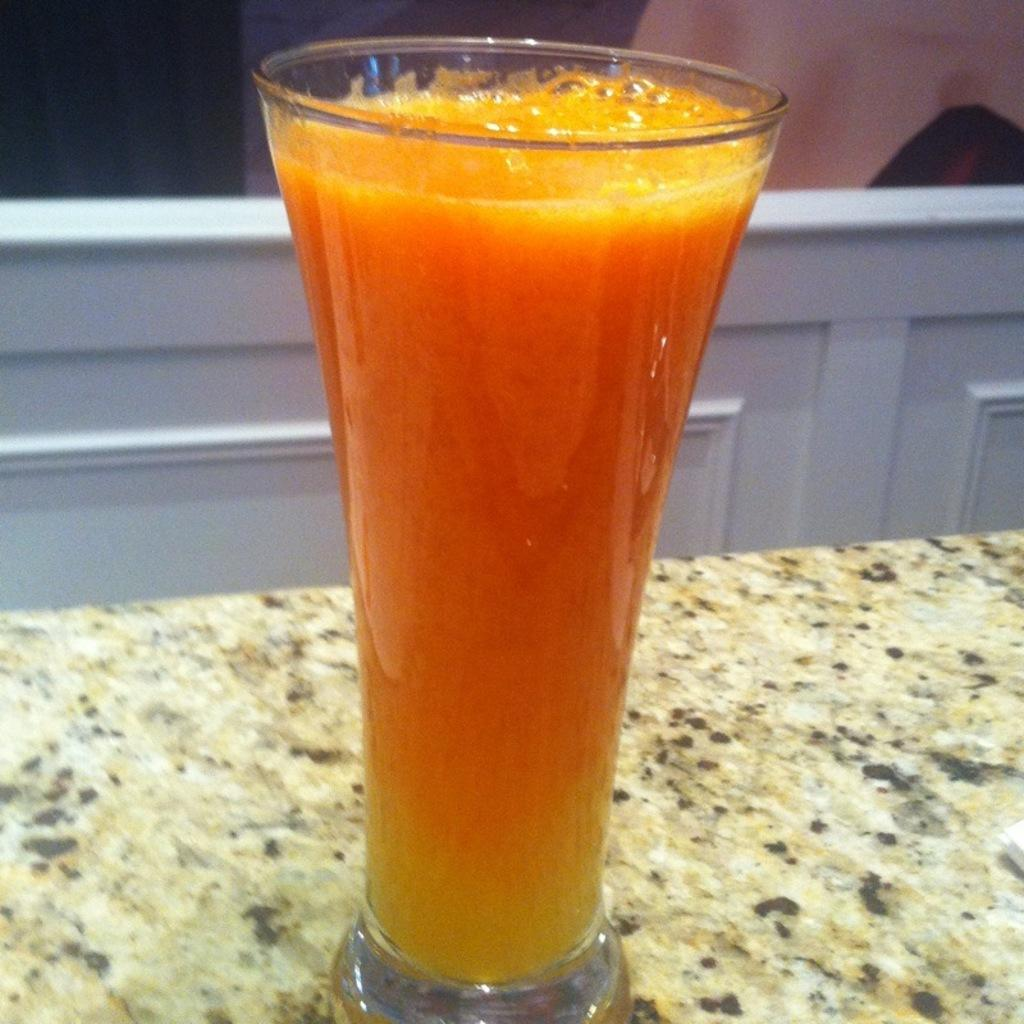What is in the glass that is visible in the image? There is a glass filled with juice in the image. Where is the glass located in the image? The glass is placed on a table. What type of zipper can be seen on the glass in the image? There is no zipper present on the glass in the image. What color is the zebra standing next to the table in the image? There is no zebra present in the image. 